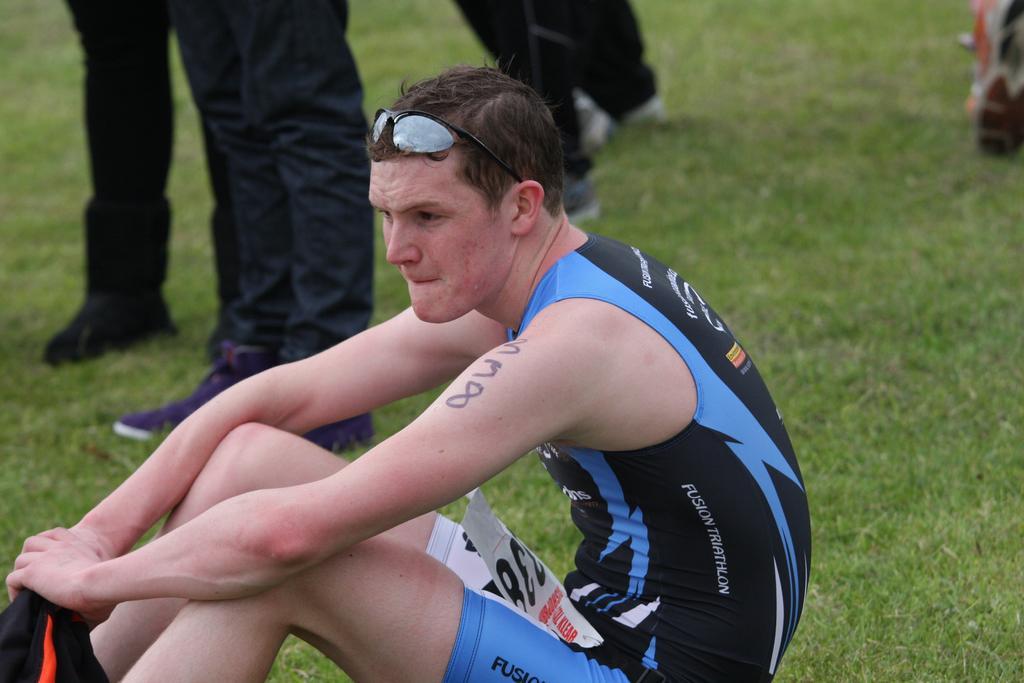In one or two sentences, can you explain what this image depicts? In front of the picture, we see a man in the blue and black T-shirt is sitting. He is wearing the goggles. At the bottom, we see the grass. In the background, we see the legs of three people. In the right top, we see an object in white, brown and orange color. 